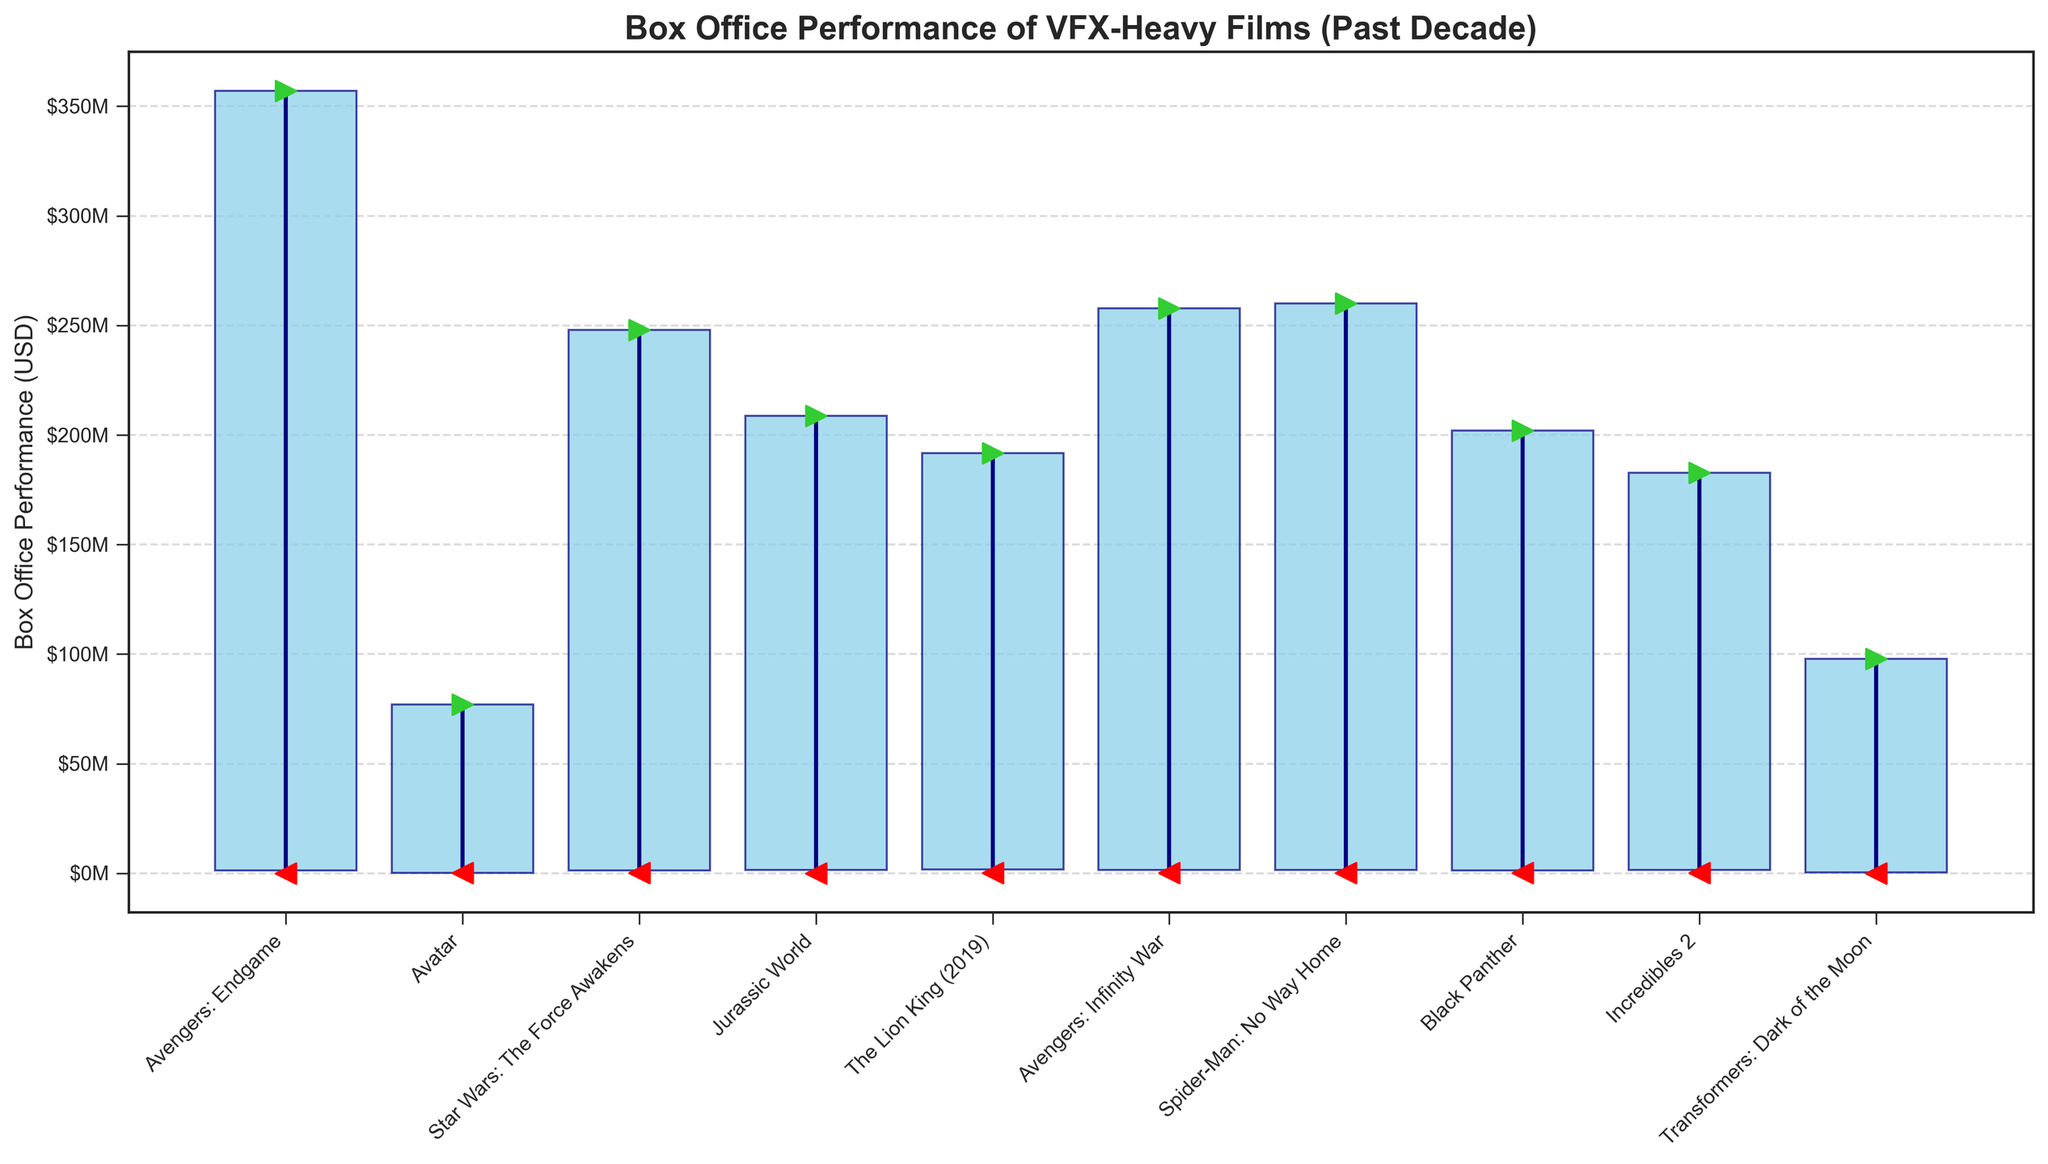What's the title of the chart? The title of the chart is written at the top of the figure. This is a typical place for titles in plots to help viewers quickly understand what the plot represents.
Answer: "Box Office Performance of VFX-Heavy Films (Past Decade)" How many films are represented in the chart? Counting the number of unique data points (films) along the x-axis will give us the number of films. Each tick label represents one film.
Answer: 10 Which film has the highest opening weekend performance? Look for the green markers indicating the opening weekend values. The highest one will indicate the film with the highest opening weekend. In this chart, "Avengers: Endgame" has the highest opening weekend value.
Answer: "Avengers: Endgame" What is the box office performance range (difference between highest and lowest weeks) for "Jurassic World"? The range is calculated by subtracting the lowest week performance from the highest week performance for "Jurassic World." This is a basic subtraction operation looking at the vertical bar for "Jurassic World."
Answer: $2,074,655 Which film had the smallest closing week performance? Look for the red markers indicating closing week values. The lowest marker among them represents the film with the smallest closing week performance. This is "Avengers: Endgame."
Answer: "Avengers: Endgame" What is the average of the highest week performances for all films? Sum the highest week values for all films and divide by the number of films. Highest week values can be found by the length of the highest blue bar segments.
Answer: $2,297,213,610.4 Which film shows the largest decrease from the highest week to the lowest week? Find the film whose bars have the largest vertical distance between the top (highest week) and the bottom (lowest week). Perform a manual comparison for each film. "Avengers: Endgame" has the largest decrease.
Answer: "Avengers: Endgame" What is the total box office performance during the closing weeks for all films? Sum the values of all closing week performances, represented by the red markers. This requires counting or reading each closing week value and adding them up.
Answer: $577,295 Which film had a higher lowest week performance, "Avatar" or "The Lion King (2019)"? Compare the lowest week values (bottom end of the blue bar) of "Avatar" and "The Lion King (2019)" to see which one has a higher value.
Answer: "The Lion King (2019)" How does the opening weekend performance of "Spider-Man: No Way Home" compare to "Black Panther"? Compare the green markers (opening week performance) of "Spider-Man: No Way Home" and "Black Panther." The marker for "Spider-Man: No Way Home" is higher.
Answer: Higher 